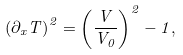<formula> <loc_0><loc_0><loc_500><loc_500>\left ( \partial _ { x } { T } \right ) ^ { 2 } = \left ( \frac { V } { V _ { 0 } } \right ) ^ { 2 } - 1 ,</formula> 